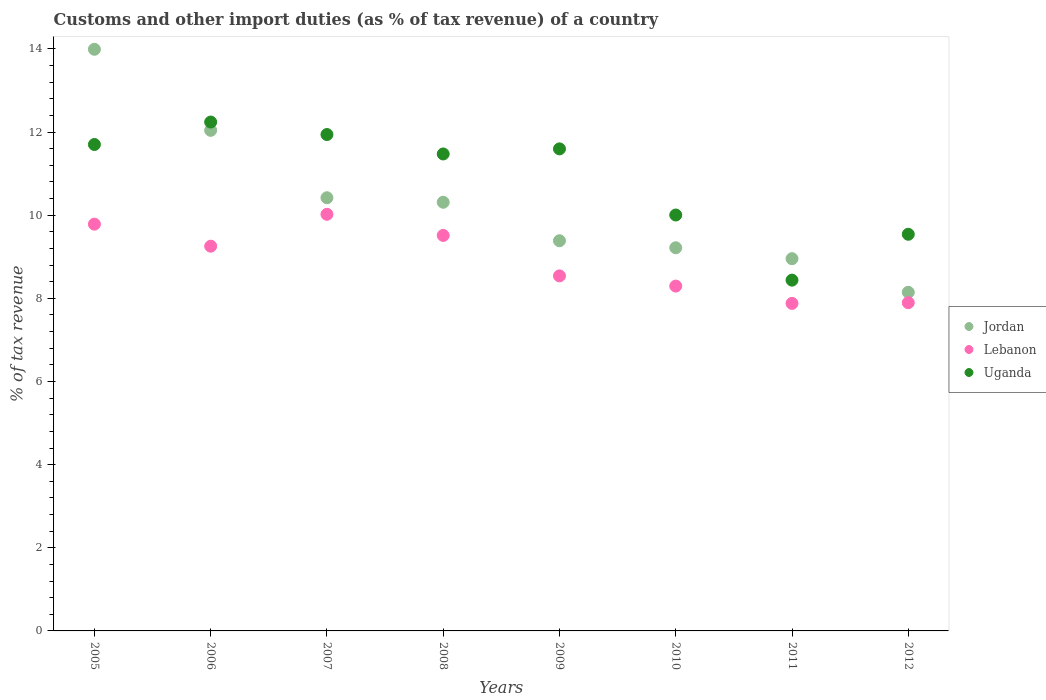How many different coloured dotlines are there?
Provide a short and direct response. 3. What is the percentage of tax revenue from customs in Jordan in 2009?
Give a very brief answer. 9.39. Across all years, what is the maximum percentage of tax revenue from customs in Jordan?
Your response must be concise. 13.99. Across all years, what is the minimum percentage of tax revenue from customs in Uganda?
Make the answer very short. 8.44. In which year was the percentage of tax revenue from customs in Uganda maximum?
Make the answer very short. 2006. In which year was the percentage of tax revenue from customs in Lebanon minimum?
Offer a very short reply. 2011. What is the total percentage of tax revenue from customs in Jordan in the graph?
Offer a terse response. 82.47. What is the difference between the percentage of tax revenue from customs in Jordan in 2008 and that in 2011?
Provide a short and direct response. 1.36. What is the difference between the percentage of tax revenue from customs in Lebanon in 2006 and the percentage of tax revenue from customs in Jordan in 2011?
Offer a very short reply. 0.3. What is the average percentage of tax revenue from customs in Uganda per year?
Offer a terse response. 10.87. In the year 2005, what is the difference between the percentage of tax revenue from customs in Uganda and percentage of tax revenue from customs in Lebanon?
Ensure brevity in your answer.  1.92. In how many years, is the percentage of tax revenue from customs in Lebanon greater than 10 %?
Offer a terse response. 1. What is the ratio of the percentage of tax revenue from customs in Uganda in 2006 to that in 2009?
Ensure brevity in your answer.  1.06. What is the difference between the highest and the second highest percentage of tax revenue from customs in Uganda?
Give a very brief answer. 0.3. What is the difference between the highest and the lowest percentage of tax revenue from customs in Lebanon?
Make the answer very short. 2.14. In how many years, is the percentage of tax revenue from customs in Lebanon greater than the average percentage of tax revenue from customs in Lebanon taken over all years?
Your answer should be compact. 4. Is the sum of the percentage of tax revenue from customs in Lebanon in 2008 and 2009 greater than the maximum percentage of tax revenue from customs in Uganda across all years?
Offer a very short reply. Yes. Is it the case that in every year, the sum of the percentage of tax revenue from customs in Uganda and percentage of tax revenue from customs in Lebanon  is greater than the percentage of tax revenue from customs in Jordan?
Give a very brief answer. Yes. Does the percentage of tax revenue from customs in Lebanon monotonically increase over the years?
Your answer should be compact. No. How many years are there in the graph?
Provide a short and direct response. 8. Are the values on the major ticks of Y-axis written in scientific E-notation?
Keep it short and to the point. No. Does the graph contain any zero values?
Offer a very short reply. No. Does the graph contain grids?
Make the answer very short. No. How many legend labels are there?
Offer a very short reply. 3. What is the title of the graph?
Provide a short and direct response. Customs and other import duties (as % of tax revenue) of a country. Does "Guatemala" appear as one of the legend labels in the graph?
Offer a terse response. No. What is the label or title of the X-axis?
Offer a very short reply. Years. What is the label or title of the Y-axis?
Provide a succinct answer. % of tax revenue. What is the % of tax revenue of Jordan in 2005?
Your answer should be compact. 13.99. What is the % of tax revenue in Lebanon in 2005?
Provide a short and direct response. 9.78. What is the % of tax revenue in Uganda in 2005?
Your response must be concise. 11.7. What is the % of tax revenue of Jordan in 2006?
Provide a short and direct response. 12.04. What is the % of tax revenue in Lebanon in 2006?
Your answer should be very brief. 9.25. What is the % of tax revenue of Uganda in 2006?
Your response must be concise. 12.24. What is the % of tax revenue of Jordan in 2007?
Offer a very short reply. 10.42. What is the % of tax revenue in Lebanon in 2007?
Your answer should be compact. 10.02. What is the % of tax revenue of Uganda in 2007?
Keep it short and to the point. 11.94. What is the % of tax revenue in Jordan in 2008?
Offer a very short reply. 10.31. What is the % of tax revenue in Lebanon in 2008?
Offer a very short reply. 9.51. What is the % of tax revenue in Uganda in 2008?
Provide a short and direct response. 11.47. What is the % of tax revenue in Jordan in 2009?
Provide a short and direct response. 9.39. What is the % of tax revenue of Lebanon in 2009?
Ensure brevity in your answer.  8.54. What is the % of tax revenue of Uganda in 2009?
Offer a very short reply. 11.6. What is the % of tax revenue in Jordan in 2010?
Offer a very short reply. 9.22. What is the % of tax revenue of Lebanon in 2010?
Your answer should be very brief. 8.3. What is the % of tax revenue of Uganda in 2010?
Your response must be concise. 10. What is the % of tax revenue of Jordan in 2011?
Give a very brief answer. 8.95. What is the % of tax revenue in Lebanon in 2011?
Offer a very short reply. 7.88. What is the % of tax revenue of Uganda in 2011?
Provide a succinct answer. 8.44. What is the % of tax revenue in Jordan in 2012?
Offer a very short reply. 8.15. What is the % of tax revenue in Lebanon in 2012?
Your response must be concise. 7.9. What is the % of tax revenue in Uganda in 2012?
Your answer should be compact. 9.54. Across all years, what is the maximum % of tax revenue of Jordan?
Provide a succinct answer. 13.99. Across all years, what is the maximum % of tax revenue in Lebanon?
Your answer should be compact. 10.02. Across all years, what is the maximum % of tax revenue in Uganda?
Your answer should be compact. 12.24. Across all years, what is the minimum % of tax revenue in Jordan?
Offer a terse response. 8.15. Across all years, what is the minimum % of tax revenue in Lebanon?
Make the answer very short. 7.88. Across all years, what is the minimum % of tax revenue in Uganda?
Make the answer very short. 8.44. What is the total % of tax revenue of Jordan in the graph?
Offer a terse response. 82.47. What is the total % of tax revenue in Lebanon in the graph?
Offer a terse response. 71.18. What is the total % of tax revenue of Uganda in the graph?
Provide a succinct answer. 86.94. What is the difference between the % of tax revenue in Jordan in 2005 and that in 2006?
Make the answer very short. 1.95. What is the difference between the % of tax revenue in Lebanon in 2005 and that in 2006?
Ensure brevity in your answer.  0.53. What is the difference between the % of tax revenue of Uganda in 2005 and that in 2006?
Give a very brief answer. -0.54. What is the difference between the % of tax revenue of Jordan in 2005 and that in 2007?
Make the answer very short. 3.57. What is the difference between the % of tax revenue in Lebanon in 2005 and that in 2007?
Provide a short and direct response. -0.24. What is the difference between the % of tax revenue in Uganda in 2005 and that in 2007?
Your response must be concise. -0.24. What is the difference between the % of tax revenue of Jordan in 2005 and that in 2008?
Provide a short and direct response. 3.68. What is the difference between the % of tax revenue of Lebanon in 2005 and that in 2008?
Ensure brevity in your answer.  0.27. What is the difference between the % of tax revenue in Uganda in 2005 and that in 2008?
Provide a short and direct response. 0.23. What is the difference between the % of tax revenue in Jordan in 2005 and that in 2009?
Provide a short and direct response. 4.61. What is the difference between the % of tax revenue of Lebanon in 2005 and that in 2009?
Offer a terse response. 1.24. What is the difference between the % of tax revenue in Uganda in 2005 and that in 2009?
Ensure brevity in your answer.  0.11. What is the difference between the % of tax revenue in Jordan in 2005 and that in 2010?
Offer a very short reply. 4.77. What is the difference between the % of tax revenue in Lebanon in 2005 and that in 2010?
Offer a very short reply. 1.49. What is the difference between the % of tax revenue in Uganda in 2005 and that in 2010?
Give a very brief answer. 1.7. What is the difference between the % of tax revenue of Jordan in 2005 and that in 2011?
Provide a short and direct response. 5.04. What is the difference between the % of tax revenue in Lebanon in 2005 and that in 2011?
Give a very brief answer. 1.91. What is the difference between the % of tax revenue in Uganda in 2005 and that in 2011?
Provide a succinct answer. 3.26. What is the difference between the % of tax revenue in Jordan in 2005 and that in 2012?
Your response must be concise. 5.85. What is the difference between the % of tax revenue of Lebanon in 2005 and that in 2012?
Make the answer very short. 1.89. What is the difference between the % of tax revenue of Uganda in 2005 and that in 2012?
Ensure brevity in your answer.  2.16. What is the difference between the % of tax revenue in Jordan in 2006 and that in 2007?
Make the answer very short. 1.62. What is the difference between the % of tax revenue in Lebanon in 2006 and that in 2007?
Your answer should be very brief. -0.77. What is the difference between the % of tax revenue of Uganda in 2006 and that in 2007?
Your response must be concise. 0.3. What is the difference between the % of tax revenue of Jordan in 2006 and that in 2008?
Your answer should be compact. 1.73. What is the difference between the % of tax revenue in Lebanon in 2006 and that in 2008?
Ensure brevity in your answer.  -0.26. What is the difference between the % of tax revenue in Uganda in 2006 and that in 2008?
Ensure brevity in your answer.  0.77. What is the difference between the % of tax revenue in Jordan in 2006 and that in 2009?
Ensure brevity in your answer.  2.66. What is the difference between the % of tax revenue in Uganda in 2006 and that in 2009?
Offer a terse response. 0.65. What is the difference between the % of tax revenue of Jordan in 2006 and that in 2010?
Provide a succinct answer. 2.82. What is the difference between the % of tax revenue of Lebanon in 2006 and that in 2010?
Your answer should be compact. 0.96. What is the difference between the % of tax revenue in Uganda in 2006 and that in 2010?
Your answer should be very brief. 2.24. What is the difference between the % of tax revenue in Jordan in 2006 and that in 2011?
Your response must be concise. 3.09. What is the difference between the % of tax revenue of Lebanon in 2006 and that in 2011?
Offer a very short reply. 1.38. What is the difference between the % of tax revenue of Uganda in 2006 and that in 2011?
Offer a very short reply. 3.8. What is the difference between the % of tax revenue of Jordan in 2006 and that in 2012?
Offer a very short reply. 3.9. What is the difference between the % of tax revenue in Lebanon in 2006 and that in 2012?
Ensure brevity in your answer.  1.36. What is the difference between the % of tax revenue of Uganda in 2006 and that in 2012?
Your answer should be compact. 2.7. What is the difference between the % of tax revenue in Jordan in 2007 and that in 2008?
Provide a short and direct response. 0.11. What is the difference between the % of tax revenue of Lebanon in 2007 and that in 2008?
Offer a very short reply. 0.51. What is the difference between the % of tax revenue in Uganda in 2007 and that in 2008?
Offer a very short reply. 0.47. What is the difference between the % of tax revenue of Jordan in 2007 and that in 2009?
Offer a terse response. 1.03. What is the difference between the % of tax revenue of Lebanon in 2007 and that in 2009?
Provide a succinct answer. 1.48. What is the difference between the % of tax revenue in Uganda in 2007 and that in 2009?
Keep it short and to the point. 0.34. What is the difference between the % of tax revenue in Jordan in 2007 and that in 2010?
Provide a short and direct response. 1.2. What is the difference between the % of tax revenue of Lebanon in 2007 and that in 2010?
Your answer should be very brief. 1.73. What is the difference between the % of tax revenue of Uganda in 2007 and that in 2010?
Offer a terse response. 1.94. What is the difference between the % of tax revenue of Jordan in 2007 and that in 2011?
Your answer should be very brief. 1.47. What is the difference between the % of tax revenue of Lebanon in 2007 and that in 2011?
Give a very brief answer. 2.14. What is the difference between the % of tax revenue in Uganda in 2007 and that in 2011?
Keep it short and to the point. 3.5. What is the difference between the % of tax revenue in Jordan in 2007 and that in 2012?
Provide a succinct answer. 2.27. What is the difference between the % of tax revenue of Lebanon in 2007 and that in 2012?
Make the answer very short. 2.13. What is the difference between the % of tax revenue of Uganda in 2007 and that in 2012?
Provide a succinct answer. 2.4. What is the difference between the % of tax revenue in Jordan in 2008 and that in 2009?
Make the answer very short. 0.93. What is the difference between the % of tax revenue of Lebanon in 2008 and that in 2009?
Provide a succinct answer. 0.97. What is the difference between the % of tax revenue of Uganda in 2008 and that in 2009?
Your response must be concise. -0.12. What is the difference between the % of tax revenue of Jordan in 2008 and that in 2010?
Provide a succinct answer. 1.09. What is the difference between the % of tax revenue in Lebanon in 2008 and that in 2010?
Make the answer very short. 1.22. What is the difference between the % of tax revenue in Uganda in 2008 and that in 2010?
Keep it short and to the point. 1.47. What is the difference between the % of tax revenue in Jordan in 2008 and that in 2011?
Offer a terse response. 1.36. What is the difference between the % of tax revenue in Lebanon in 2008 and that in 2011?
Ensure brevity in your answer.  1.64. What is the difference between the % of tax revenue in Uganda in 2008 and that in 2011?
Your response must be concise. 3.04. What is the difference between the % of tax revenue of Jordan in 2008 and that in 2012?
Provide a succinct answer. 2.17. What is the difference between the % of tax revenue in Lebanon in 2008 and that in 2012?
Provide a short and direct response. 1.62. What is the difference between the % of tax revenue of Uganda in 2008 and that in 2012?
Provide a short and direct response. 1.93. What is the difference between the % of tax revenue in Jordan in 2009 and that in 2010?
Offer a very short reply. 0.17. What is the difference between the % of tax revenue of Lebanon in 2009 and that in 2010?
Ensure brevity in your answer.  0.25. What is the difference between the % of tax revenue in Uganda in 2009 and that in 2010?
Offer a very short reply. 1.59. What is the difference between the % of tax revenue of Jordan in 2009 and that in 2011?
Your answer should be compact. 0.43. What is the difference between the % of tax revenue of Lebanon in 2009 and that in 2011?
Provide a succinct answer. 0.66. What is the difference between the % of tax revenue of Uganda in 2009 and that in 2011?
Make the answer very short. 3.16. What is the difference between the % of tax revenue of Jordan in 2009 and that in 2012?
Offer a terse response. 1.24. What is the difference between the % of tax revenue in Lebanon in 2009 and that in 2012?
Provide a short and direct response. 0.64. What is the difference between the % of tax revenue in Uganda in 2009 and that in 2012?
Your response must be concise. 2.05. What is the difference between the % of tax revenue of Jordan in 2010 and that in 2011?
Give a very brief answer. 0.26. What is the difference between the % of tax revenue of Lebanon in 2010 and that in 2011?
Offer a very short reply. 0.42. What is the difference between the % of tax revenue in Uganda in 2010 and that in 2011?
Make the answer very short. 1.57. What is the difference between the % of tax revenue in Jordan in 2010 and that in 2012?
Offer a terse response. 1.07. What is the difference between the % of tax revenue in Lebanon in 2010 and that in 2012?
Provide a succinct answer. 0.4. What is the difference between the % of tax revenue of Uganda in 2010 and that in 2012?
Keep it short and to the point. 0.46. What is the difference between the % of tax revenue in Jordan in 2011 and that in 2012?
Offer a terse response. 0.81. What is the difference between the % of tax revenue of Lebanon in 2011 and that in 2012?
Offer a very short reply. -0.02. What is the difference between the % of tax revenue in Uganda in 2011 and that in 2012?
Your answer should be very brief. -1.1. What is the difference between the % of tax revenue in Jordan in 2005 and the % of tax revenue in Lebanon in 2006?
Offer a very short reply. 4.74. What is the difference between the % of tax revenue in Jordan in 2005 and the % of tax revenue in Uganda in 2006?
Your answer should be very brief. 1.75. What is the difference between the % of tax revenue in Lebanon in 2005 and the % of tax revenue in Uganda in 2006?
Provide a succinct answer. -2.46. What is the difference between the % of tax revenue of Jordan in 2005 and the % of tax revenue of Lebanon in 2007?
Give a very brief answer. 3.97. What is the difference between the % of tax revenue in Jordan in 2005 and the % of tax revenue in Uganda in 2007?
Make the answer very short. 2.05. What is the difference between the % of tax revenue in Lebanon in 2005 and the % of tax revenue in Uganda in 2007?
Make the answer very short. -2.16. What is the difference between the % of tax revenue in Jordan in 2005 and the % of tax revenue in Lebanon in 2008?
Make the answer very short. 4.48. What is the difference between the % of tax revenue in Jordan in 2005 and the % of tax revenue in Uganda in 2008?
Offer a very short reply. 2.52. What is the difference between the % of tax revenue of Lebanon in 2005 and the % of tax revenue of Uganda in 2008?
Provide a short and direct response. -1.69. What is the difference between the % of tax revenue of Jordan in 2005 and the % of tax revenue of Lebanon in 2009?
Your answer should be very brief. 5.45. What is the difference between the % of tax revenue in Jordan in 2005 and the % of tax revenue in Uganda in 2009?
Keep it short and to the point. 2.4. What is the difference between the % of tax revenue in Lebanon in 2005 and the % of tax revenue in Uganda in 2009?
Your answer should be compact. -1.81. What is the difference between the % of tax revenue in Jordan in 2005 and the % of tax revenue in Lebanon in 2010?
Your response must be concise. 5.7. What is the difference between the % of tax revenue in Jordan in 2005 and the % of tax revenue in Uganda in 2010?
Your response must be concise. 3.99. What is the difference between the % of tax revenue in Lebanon in 2005 and the % of tax revenue in Uganda in 2010?
Your response must be concise. -0.22. What is the difference between the % of tax revenue of Jordan in 2005 and the % of tax revenue of Lebanon in 2011?
Your response must be concise. 6.11. What is the difference between the % of tax revenue in Jordan in 2005 and the % of tax revenue in Uganda in 2011?
Offer a terse response. 5.55. What is the difference between the % of tax revenue in Lebanon in 2005 and the % of tax revenue in Uganda in 2011?
Your answer should be very brief. 1.35. What is the difference between the % of tax revenue in Jordan in 2005 and the % of tax revenue in Lebanon in 2012?
Make the answer very short. 6.1. What is the difference between the % of tax revenue of Jordan in 2005 and the % of tax revenue of Uganda in 2012?
Your answer should be compact. 4.45. What is the difference between the % of tax revenue in Lebanon in 2005 and the % of tax revenue in Uganda in 2012?
Provide a short and direct response. 0.24. What is the difference between the % of tax revenue in Jordan in 2006 and the % of tax revenue in Lebanon in 2007?
Your answer should be compact. 2.02. What is the difference between the % of tax revenue of Jordan in 2006 and the % of tax revenue of Uganda in 2007?
Your response must be concise. 0.1. What is the difference between the % of tax revenue of Lebanon in 2006 and the % of tax revenue of Uganda in 2007?
Provide a short and direct response. -2.69. What is the difference between the % of tax revenue in Jordan in 2006 and the % of tax revenue in Lebanon in 2008?
Provide a short and direct response. 2.53. What is the difference between the % of tax revenue in Jordan in 2006 and the % of tax revenue in Uganda in 2008?
Give a very brief answer. 0.57. What is the difference between the % of tax revenue in Lebanon in 2006 and the % of tax revenue in Uganda in 2008?
Ensure brevity in your answer.  -2.22. What is the difference between the % of tax revenue of Jordan in 2006 and the % of tax revenue of Lebanon in 2009?
Provide a short and direct response. 3.5. What is the difference between the % of tax revenue in Jordan in 2006 and the % of tax revenue in Uganda in 2009?
Offer a very short reply. 0.45. What is the difference between the % of tax revenue of Lebanon in 2006 and the % of tax revenue of Uganda in 2009?
Offer a very short reply. -2.34. What is the difference between the % of tax revenue in Jordan in 2006 and the % of tax revenue in Lebanon in 2010?
Make the answer very short. 3.75. What is the difference between the % of tax revenue of Jordan in 2006 and the % of tax revenue of Uganda in 2010?
Your response must be concise. 2.04. What is the difference between the % of tax revenue of Lebanon in 2006 and the % of tax revenue of Uganda in 2010?
Your response must be concise. -0.75. What is the difference between the % of tax revenue of Jordan in 2006 and the % of tax revenue of Lebanon in 2011?
Keep it short and to the point. 4.16. What is the difference between the % of tax revenue in Jordan in 2006 and the % of tax revenue in Uganda in 2011?
Give a very brief answer. 3.6. What is the difference between the % of tax revenue in Lebanon in 2006 and the % of tax revenue in Uganda in 2011?
Offer a terse response. 0.82. What is the difference between the % of tax revenue of Jordan in 2006 and the % of tax revenue of Lebanon in 2012?
Offer a very short reply. 4.15. What is the difference between the % of tax revenue of Jordan in 2006 and the % of tax revenue of Uganda in 2012?
Offer a terse response. 2.5. What is the difference between the % of tax revenue in Lebanon in 2006 and the % of tax revenue in Uganda in 2012?
Provide a succinct answer. -0.29. What is the difference between the % of tax revenue in Jordan in 2007 and the % of tax revenue in Lebanon in 2008?
Your answer should be compact. 0.91. What is the difference between the % of tax revenue in Jordan in 2007 and the % of tax revenue in Uganda in 2008?
Ensure brevity in your answer.  -1.05. What is the difference between the % of tax revenue of Lebanon in 2007 and the % of tax revenue of Uganda in 2008?
Provide a succinct answer. -1.45. What is the difference between the % of tax revenue in Jordan in 2007 and the % of tax revenue in Lebanon in 2009?
Provide a succinct answer. 1.88. What is the difference between the % of tax revenue in Jordan in 2007 and the % of tax revenue in Uganda in 2009?
Make the answer very short. -1.18. What is the difference between the % of tax revenue in Lebanon in 2007 and the % of tax revenue in Uganda in 2009?
Your answer should be compact. -1.57. What is the difference between the % of tax revenue of Jordan in 2007 and the % of tax revenue of Lebanon in 2010?
Make the answer very short. 2.12. What is the difference between the % of tax revenue in Jordan in 2007 and the % of tax revenue in Uganda in 2010?
Your answer should be very brief. 0.42. What is the difference between the % of tax revenue in Lebanon in 2007 and the % of tax revenue in Uganda in 2010?
Offer a very short reply. 0.02. What is the difference between the % of tax revenue in Jordan in 2007 and the % of tax revenue in Lebanon in 2011?
Ensure brevity in your answer.  2.54. What is the difference between the % of tax revenue of Jordan in 2007 and the % of tax revenue of Uganda in 2011?
Provide a succinct answer. 1.98. What is the difference between the % of tax revenue of Lebanon in 2007 and the % of tax revenue of Uganda in 2011?
Provide a short and direct response. 1.58. What is the difference between the % of tax revenue of Jordan in 2007 and the % of tax revenue of Lebanon in 2012?
Keep it short and to the point. 2.52. What is the difference between the % of tax revenue of Jordan in 2007 and the % of tax revenue of Uganda in 2012?
Offer a very short reply. 0.88. What is the difference between the % of tax revenue in Lebanon in 2007 and the % of tax revenue in Uganda in 2012?
Your response must be concise. 0.48. What is the difference between the % of tax revenue of Jordan in 2008 and the % of tax revenue of Lebanon in 2009?
Give a very brief answer. 1.77. What is the difference between the % of tax revenue in Jordan in 2008 and the % of tax revenue in Uganda in 2009?
Your response must be concise. -1.28. What is the difference between the % of tax revenue in Lebanon in 2008 and the % of tax revenue in Uganda in 2009?
Ensure brevity in your answer.  -2.08. What is the difference between the % of tax revenue of Jordan in 2008 and the % of tax revenue of Lebanon in 2010?
Your answer should be very brief. 2.02. What is the difference between the % of tax revenue of Jordan in 2008 and the % of tax revenue of Uganda in 2010?
Make the answer very short. 0.31. What is the difference between the % of tax revenue in Lebanon in 2008 and the % of tax revenue in Uganda in 2010?
Offer a very short reply. -0.49. What is the difference between the % of tax revenue of Jordan in 2008 and the % of tax revenue of Lebanon in 2011?
Provide a short and direct response. 2.43. What is the difference between the % of tax revenue of Jordan in 2008 and the % of tax revenue of Uganda in 2011?
Provide a succinct answer. 1.87. What is the difference between the % of tax revenue in Lebanon in 2008 and the % of tax revenue in Uganda in 2011?
Offer a very short reply. 1.08. What is the difference between the % of tax revenue in Jordan in 2008 and the % of tax revenue in Lebanon in 2012?
Offer a very short reply. 2.42. What is the difference between the % of tax revenue in Jordan in 2008 and the % of tax revenue in Uganda in 2012?
Make the answer very short. 0.77. What is the difference between the % of tax revenue of Lebanon in 2008 and the % of tax revenue of Uganda in 2012?
Your answer should be compact. -0.03. What is the difference between the % of tax revenue in Jordan in 2009 and the % of tax revenue in Lebanon in 2010?
Ensure brevity in your answer.  1.09. What is the difference between the % of tax revenue of Jordan in 2009 and the % of tax revenue of Uganda in 2010?
Your response must be concise. -0.62. What is the difference between the % of tax revenue in Lebanon in 2009 and the % of tax revenue in Uganda in 2010?
Provide a short and direct response. -1.46. What is the difference between the % of tax revenue of Jordan in 2009 and the % of tax revenue of Lebanon in 2011?
Your answer should be compact. 1.51. What is the difference between the % of tax revenue of Jordan in 2009 and the % of tax revenue of Uganda in 2011?
Your answer should be compact. 0.95. What is the difference between the % of tax revenue in Lebanon in 2009 and the % of tax revenue in Uganda in 2011?
Give a very brief answer. 0.1. What is the difference between the % of tax revenue in Jordan in 2009 and the % of tax revenue in Lebanon in 2012?
Your response must be concise. 1.49. What is the difference between the % of tax revenue in Jordan in 2009 and the % of tax revenue in Uganda in 2012?
Offer a very short reply. -0.16. What is the difference between the % of tax revenue of Lebanon in 2009 and the % of tax revenue of Uganda in 2012?
Offer a terse response. -1. What is the difference between the % of tax revenue of Jordan in 2010 and the % of tax revenue of Lebanon in 2011?
Make the answer very short. 1.34. What is the difference between the % of tax revenue of Jordan in 2010 and the % of tax revenue of Uganda in 2011?
Offer a terse response. 0.78. What is the difference between the % of tax revenue of Lebanon in 2010 and the % of tax revenue of Uganda in 2011?
Your answer should be compact. -0.14. What is the difference between the % of tax revenue of Jordan in 2010 and the % of tax revenue of Lebanon in 2012?
Provide a succinct answer. 1.32. What is the difference between the % of tax revenue of Jordan in 2010 and the % of tax revenue of Uganda in 2012?
Your answer should be very brief. -0.32. What is the difference between the % of tax revenue of Lebanon in 2010 and the % of tax revenue of Uganda in 2012?
Make the answer very short. -1.25. What is the difference between the % of tax revenue in Jordan in 2011 and the % of tax revenue in Lebanon in 2012?
Provide a succinct answer. 1.06. What is the difference between the % of tax revenue of Jordan in 2011 and the % of tax revenue of Uganda in 2012?
Offer a terse response. -0.59. What is the difference between the % of tax revenue in Lebanon in 2011 and the % of tax revenue in Uganda in 2012?
Offer a terse response. -1.66. What is the average % of tax revenue of Jordan per year?
Provide a short and direct response. 10.31. What is the average % of tax revenue in Lebanon per year?
Provide a short and direct response. 8.9. What is the average % of tax revenue in Uganda per year?
Your response must be concise. 10.87. In the year 2005, what is the difference between the % of tax revenue of Jordan and % of tax revenue of Lebanon?
Your answer should be compact. 4.21. In the year 2005, what is the difference between the % of tax revenue of Jordan and % of tax revenue of Uganda?
Give a very brief answer. 2.29. In the year 2005, what is the difference between the % of tax revenue in Lebanon and % of tax revenue in Uganda?
Offer a very short reply. -1.92. In the year 2006, what is the difference between the % of tax revenue in Jordan and % of tax revenue in Lebanon?
Give a very brief answer. 2.79. In the year 2006, what is the difference between the % of tax revenue of Jordan and % of tax revenue of Uganda?
Make the answer very short. -0.2. In the year 2006, what is the difference between the % of tax revenue in Lebanon and % of tax revenue in Uganda?
Your answer should be very brief. -2.99. In the year 2007, what is the difference between the % of tax revenue in Jordan and % of tax revenue in Lebanon?
Make the answer very short. 0.4. In the year 2007, what is the difference between the % of tax revenue of Jordan and % of tax revenue of Uganda?
Your response must be concise. -1.52. In the year 2007, what is the difference between the % of tax revenue of Lebanon and % of tax revenue of Uganda?
Ensure brevity in your answer.  -1.92. In the year 2008, what is the difference between the % of tax revenue of Jordan and % of tax revenue of Lebanon?
Ensure brevity in your answer.  0.8. In the year 2008, what is the difference between the % of tax revenue of Jordan and % of tax revenue of Uganda?
Your answer should be compact. -1.16. In the year 2008, what is the difference between the % of tax revenue in Lebanon and % of tax revenue in Uganda?
Provide a short and direct response. -1.96. In the year 2009, what is the difference between the % of tax revenue of Jordan and % of tax revenue of Lebanon?
Make the answer very short. 0.85. In the year 2009, what is the difference between the % of tax revenue of Jordan and % of tax revenue of Uganda?
Your response must be concise. -2.21. In the year 2009, what is the difference between the % of tax revenue in Lebanon and % of tax revenue in Uganda?
Ensure brevity in your answer.  -3.06. In the year 2010, what is the difference between the % of tax revenue in Jordan and % of tax revenue in Lebanon?
Make the answer very short. 0.92. In the year 2010, what is the difference between the % of tax revenue in Jordan and % of tax revenue in Uganda?
Your answer should be compact. -0.79. In the year 2010, what is the difference between the % of tax revenue in Lebanon and % of tax revenue in Uganda?
Your answer should be compact. -1.71. In the year 2011, what is the difference between the % of tax revenue in Jordan and % of tax revenue in Lebanon?
Your response must be concise. 1.08. In the year 2011, what is the difference between the % of tax revenue in Jordan and % of tax revenue in Uganda?
Make the answer very short. 0.52. In the year 2011, what is the difference between the % of tax revenue of Lebanon and % of tax revenue of Uganda?
Your answer should be compact. -0.56. In the year 2012, what is the difference between the % of tax revenue in Jordan and % of tax revenue in Lebanon?
Make the answer very short. 0.25. In the year 2012, what is the difference between the % of tax revenue in Jordan and % of tax revenue in Uganda?
Ensure brevity in your answer.  -1.4. In the year 2012, what is the difference between the % of tax revenue in Lebanon and % of tax revenue in Uganda?
Your answer should be compact. -1.65. What is the ratio of the % of tax revenue of Jordan in 2005 to that in 2006?
Provide a succinct answer. 1.16. What is the ratio of the % of tax revenue in Lebanon in 2005 to that in 2006?
Your response must be concise. 1.06. What is the ratio of the % of tax revenue of Uganda in 2005 to that in 2006?
Give a very brief answer. 0.96. What is the ratio of the % of tax revenue in Jordan in 2005 to that in 2007?
Offer a terse response. 1.34. What is the ratio of the % of tax revenue in Lebanon in 2005 to that in 2007?
Offer a very short reply. 0.98. What is the ratio of the % of tax revenue in Uganda in 2005 to that in 2007?
Make the answer very short. 0.98. What is the ratio of the % of tax revenue of Jordan in 2005 to that in 2008?
Your answer should be very brief. 1.36. What is the ratio of the % of tax revenue in Lebanon in 2005 to that in 2008?
Make the answer very short. 1.03. What is the ratio of the % of tax revenue of Uganda in 2005 to that in 2008?
Make the answer very short. 1.02. What is the ratio of the % of tax revenue of Jordan in 2005 to that in 2009?
Provide a short and direct response. 1.49. What is the ratio of the % of tax revenue of Lebanon in 2005 to that in 2009?
Provide a short and direct response. 1.15. What is the ratio of the % of tax revenue of Uganda in 2005 to that in 2009?
Ensure brevity in your answer.  1.01. What is the ratio of the % of tax revenue of Jordan in 2005 to that in 2010?
Your answer should be compact. 1.52. What is the ratio of the % of tax revenue of Lebanon in 2005 to that in 2010?
Ensure brevity in your answer.  1.18. What is the ratio of the % of tax revenue in Uganda in 2005 to that in 2010?
Your answer should be very brief. 1.17. What is the ratio of the % of tax revenue of Jordan in 2005 to that in 2011?
Your response must be concise. 1.56. What is the ratio of the % of tax revenue of Lebanon in 2005 to that in 2011?
Your answer should be very brief. 1.24. What is the ratio of the % of tax revenue in Uganda in 2005 to that in 2011?
Your answer should be compact. 1.39. What is the ratio of the % of tax revenue in Jordan in 2005 to that in 2012?
Your answer should be compact. 1.72. What is the ratio of the % of tax revenue in Lebanon in 2005 to that in 2012?
Provide a succinct answer. 1.24. What is the ratio of the % of tax revenue in Uganda in 2005 to that in 2012?
Give a very brief answer. 1.23. What is the ratio of the % of tax revenue in Jordan in 2006 to that in 2007?
Offer a terse response. 1.16. What is the ratio of the % of tax revenue in Lebanon in 2006 to that in 2007?
Keep it short and to the point. 0.92. What is the ratio of the % of tax revenue in Uganda in 2006 to that in 2007?
Ensure brevity in your answer.  1.03. What is the ratio of the % of tax revenue in Jordan in 2006 to that in 2008?
Keep it short and to the point. 1.17. What is the ratio of the % of tax revenue in Lebanon in 2006 to that in 2008?
Make the answer very short. 0.97. What is the ratio of the % of tax revenue in Uganda in 2006 to that in 2008?
Make the answer very short. 1.07. What is the ratio of the % of tax revenue of Jordan in 2006 to that in 2009?
Keep it short and to the point. 1.28. What is the ratio of the % of tax revenue in Lebanon in 2006 to that in 2009?
Give a very brief answer. 1.08. What is the ratio of the % of tax revenue of Uganda in 2006 to that in 2009?
Keep it short and to the point. 1.06. What is the ratio of the % of tax revenue in Jordan in 2006 to that in 2010?
Your answer should be very brief. 1.31. What is the ratio of the % of tax revenue of Lebanon in 2006 to that in 2010?
Provide a succinct answer. 1.12. What is the ratio of the % of tax revenue of Uganda in 2006 to that in 2010?
Keep it short and to the point. 1.22. What is the ratio of the % of tax revenue of Jordan in 2006 to that in 2011?
Keep it short and to the point. 1.34. What is the ratio of the % of tax revenue in Lebanon in 2006 to that in 2011?
Give a very brief answer. 1.17. What is the ratio of the % of tax revenue in Uganda in 2006 to that in 2011?
Your answer should be very brief. 1.45. What is the ratio of the % of tax revenue of Jordan in 2006 to that in 2012?
Make the answer very short. 1.48. What is the ratio of the % of tax revenue in Lebanon in 2006 to that in 2012?
Your response must be concise. 1.17. What is the ratio of the % of tax revenue in Uganda in 2006 to that in 2012?
Provide a short and direct response. 1.28. What is the ratio of the % of tax revenue in Jordan in 2007 to that in 2008?
Your answer should be compact. 1.01. What is the ratio of the % of tax revenue of Lebanon in 2007 to that in 2008?
Offer a very short reply. 1.05. What is the ratio of the % of tax revenue of Uganda in 2007 to that in 2008?
Your answer should be compact. 1.04. What is the ratio of the % of tax revenue in Jordan in 2007 to that in 2009?
Keep it short and to the point. 1.11. What is the ratio of the % of tax revenue of Lebanon in 2007 to that in 2009?
Your answer should be very brief. 1.17. What is the ratio of the % of tax revenue of Uganda in 2007 to that in 2009?
Your answer should be very brief. 1.03. What is the ratio of the % of tax revenue of Jordan in 2007 to that in 2010?
Provide a succinct answer. 1.13. What is the ratio of the % of tax revenue of Lebanon in 2007 to that in 2010?
Provide a succinct answer. 1.21. What is the ratio of the % of tax revenue in Uganda in 2007 to that in 2010?
Ensure brevity in your answer.  1.19. What is the ratio of the % of tax revenue in Jordan in 2007 to that in 2011?
Ensure brevity in your answer.  1.16. What is the ratio of the % of tax revenue in Lebanon in 2007 to that in 2011?
Your answer should be very brief. 1.27. What is the ratio of the % of tax revenue in Uganda in 2007 to that in 2011?
Your answer should be very brief. 1.42. What is the ratio of the % of tax revenue in Jordan in 2007 to that in 2012?
Your answer should be very brief. 1.28. What is the ratio of the % of tax revenue of Lebanon in 2007 to that in 2012?
Your response must be concise. 1.27. What is the ratio of the % of tax revenue of Uganda in 2007 to that in 2012?
Give a very brief answer. 1.25. What is the ratio of the % of tax revenue in Jordan in 2008 to that in 2009?
Your answer should be compact. 1.1. What is the ratio of the % of tax revenue in Lebanon in 2008 to that in 2009?
Offer a terse response. 1.11. What is the ratio of the % of tax revenue in Jordan in 2008 to that in 2010?
Make the answer very short. 1.12. What is the ratio of the % of tax revenue in Lebanon in 2008 to that in 2010?
Your answer should be compact. 1.15. What is the ratio of the % of tax revenue in Uganda in 2008 to that in 2010?
Offer a very short reply. 1.15. What is the ratio of the % of tax revenue of Jordan in 2008 to that in 2011?
Offer a terse response. 1.15. What is the ratio of the % of tax revenue of Lebanon in 2008 to that in 2011?
Give a very brief answer. 1.21. What is the ratio of the % of tax revenue in Uganda in 2008 to that in 2011?
Your answer should be very brief. 1.36. What is the ratio of the % of tax revenue in Jordan in 2008 to that in 2012?
Your answer should be very brief. 1.27. What is the ratio of the % of tax revenue of Lebanon in 2008 to that in 2012?
Offer a terse response. 1.2. What is the ratio of the % of tax revenue of Uganda in 2008 to that in 2012?
Keep it short and to the point. 1.2. What is the ratio of the % of tax revenue of Jordan in 2009 to that in 2010?
Provide a short and direct response. 1.02. What is the ratio of the % of tax revenue of Lebanon in 2009 to that in 2010?
Your answer should be compact. 1.03. What is the ratio of the % of tax revenue in Uganda in 2009 to that in 2010?
Provide a succinct answer. 1.16. What is the ratio of the % of tax revenue in Jordan in 2009 to that in 2011?
Your answer should be very brief. 1.05. What is the ratio of the % of tax revenue of Lebanon in 2009 to that in 2011?
Give a very brief answer. 1.08. What is the ratio of the % of tax revenue of Uganda in 2009 to that in 2011?
Offer a very short reply. 1.37. What is the ratio of the % of tax revenue in Jordan in 2009 to that in 2012?
Your answer should be compact. 1.15. What is the ratio of the % of tax revenue of Lebanon in 2009 to that in 2012?
Your answer should be compact. 1.08. What is the ratio of the % of tax revenue of Uganda in 2009 to that in 2012?
Provide a short and direct response. 1.22. What is the ratio of the % of tax revenue of Jordan in 2010 to that in 2011?
Give a very brief answer. 1.03. What is the ratio of the % of tax revenue of Lebanon in 2010 to that in 2011?
Provide a succinct answer. 1.05. What is the ratio of the % of tax revenue of Uganda in 2010 to that in 2011?
Your answer should be compact. 1.19. What is the ratio of the % of tax revenue in Jordan in 2010 to that in 2012?
Give a very brief answer. 1.13. What is the ratio of the % of tax revenue of Lebanon in 2010 to that in 2012?
Keep it short and to the point. 1.05. What is the ratio of the % of tax revenue in Uganda in 2010 to that in 2012?
Ensure brevity in your answer.  1.05. What is the ratio of the % of tax revenue of Jordan in 2011 to that in 2012?
Ensure brevity in your answer.  1.1. What is the ratio of the % of tax revenue of Lebanon in 2011 to that in 2012?
Your answer should be compact. 1. What is the ratio of the % of tax revenue of Uganda in 2011 to that in 2012?
Offer a very short reply. 0.88. What is the difference between the highest and the second highest % of tax revenue of Jordan?
Ensure brevity in your answer.  1.95. What is the difference between the highest and the second highest % of tax revenue in Lebanon?
Ensure brevity in your answer.  0.24. What is the difference between the highest and the second highest % of tax revenue of Uganda?
Offer a very short reply. 0.3. What is the difference between the highest and the lowest % of tax revenue of Jordan?
Provide a succinct answer. 5.85. What is the difference between the highest and the lowest % of tax revenue in Lebanon?
Give a very brief answer. 2.14. What is the difference between the highest and the lowest % of tax revenue of Uganda?
Your response must be concise. 3.8. 